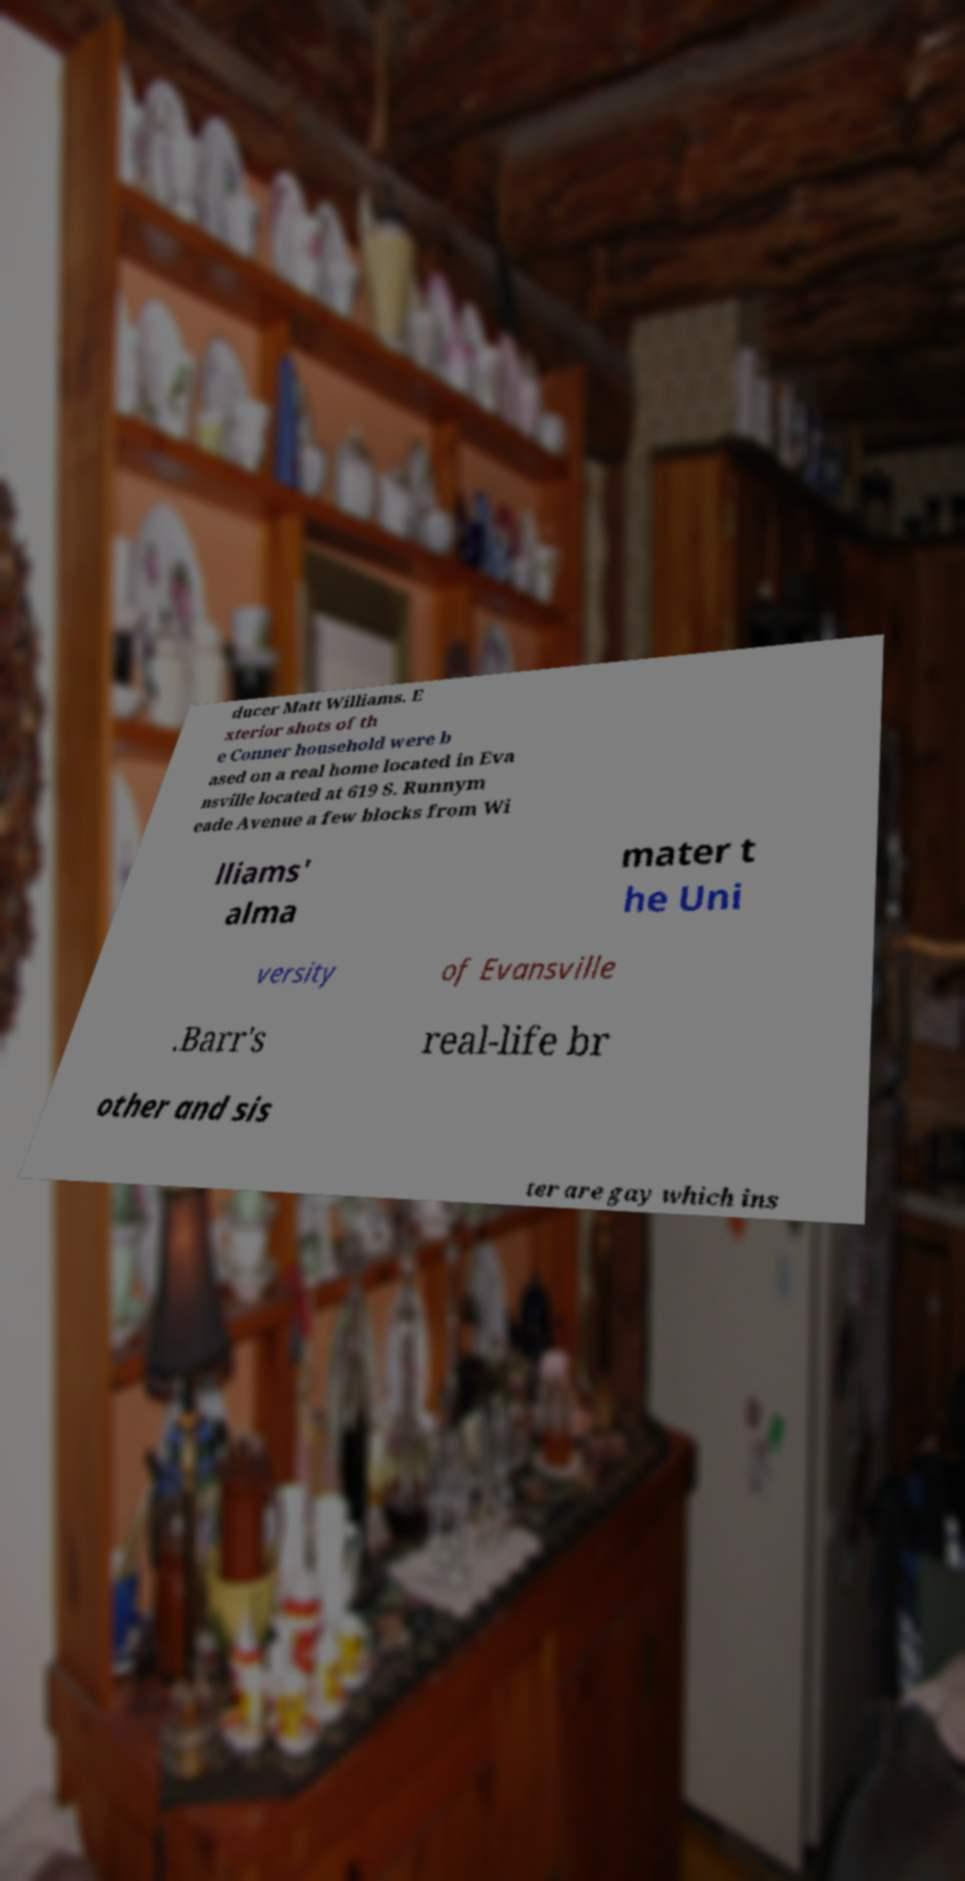There's text embedded in this image that I need extracted. Can you transcribe it verbatim? ducer Matt Williams. E xterior shots of th e Conner household were b ased on a real home located in Eva nsville located at 619 S. Runnym eade Avenue a few blocks from Wi lliams' alma mater t he Uni versity of Evansville .Barr's real-life br other and sis ter are gay which ins 